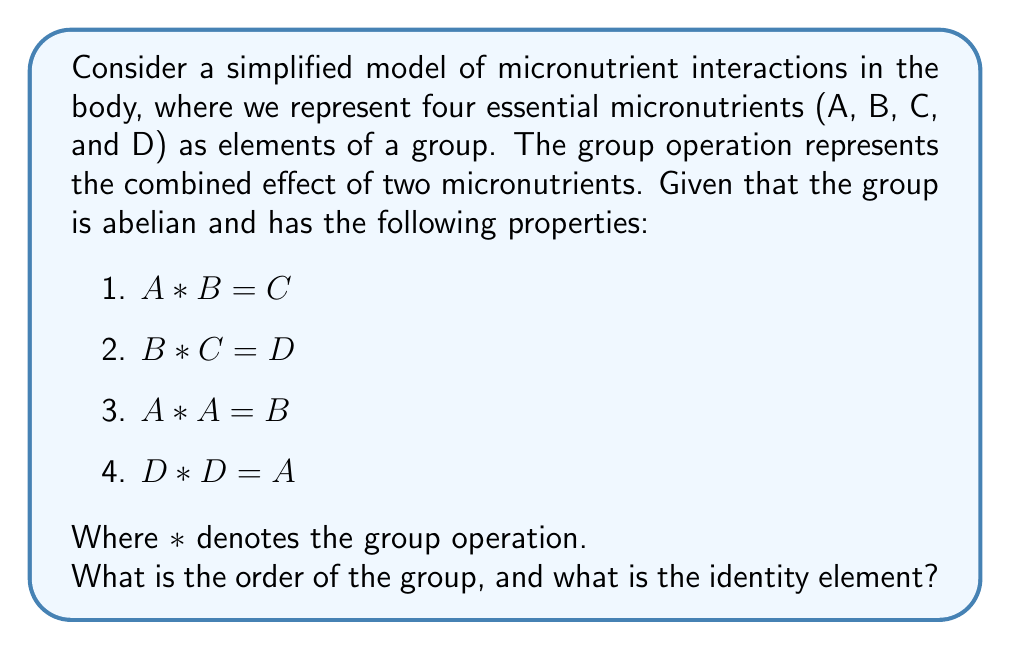Could you help me with this problem? Let's approach this step-by-step:

1) First, we need to determine all elements of the group. We're given A, B, C, and D.

2) Next, we need to check if there are any other elements. Since A * A = B, B * C = D, and D * D = A, we can see that these four elements are closed under the operation. No new elements are generated.

3) The group is abelian, which means the operation is commutative: x * y = y * x for all elements x and y.

4) To find the identity element, let's call it e. We need to find an element that satisfies x * e = x for all x in the group.

5) Let's consider each possibility:
   - If A were the identity: A * B = B, but we know A * B = C, so A is not the identity.
   - If B were the identity: A * B = A, but we know A * B = C, so B is not the identity.
   - If C were the identity: B * C = B, but we know B * C = D, so C is not the identity.
   - If D were the identity: A * D = A, B * D = B, C * D = C, and D * D = D.

6) We can see that D satisfies the property of the identity element for A, B, and C. We also know that D * D = A, which means D * D * D = A * D = A, confirming that D is indeed the identity element.

7) The order of a group is the number of elements in the group. We have identified four elements (A, B, C, and D) and confirmed that no other elements exist in the group.

Therefore, the order of the group is 4, and the identity element is D.
Answer: Order: 4, Identity: D 